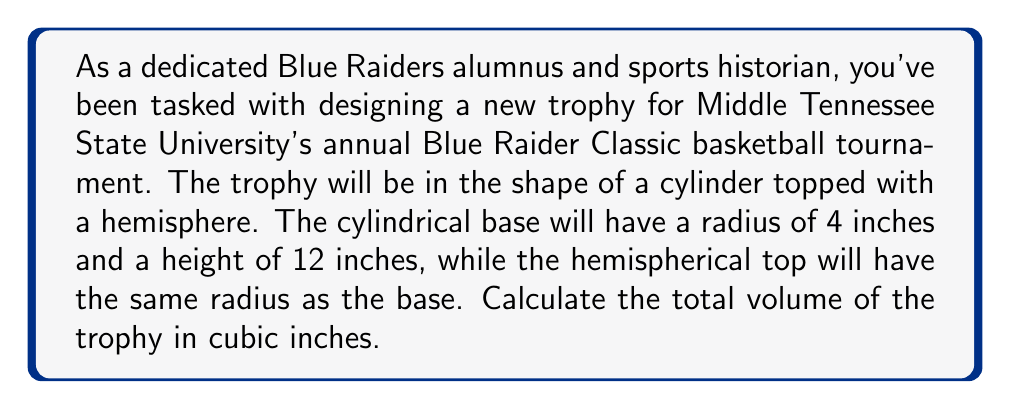Provide a solution to this math problem. Let's break this problem down into steps:

1. Calculate the volume of the cylindrical base:
   The formula for the volume of a cylinder is $V_c = \pi r^2 h$
   Where $r$ is the radius and $h$ is the height
   $$V_c = \pi (4\text{ in})^2 (12\text{ in}) = 192\pi \text{ in}^3$$

2. Calculate the volume of the hemispherical top:
   The formula for the volume of a sphere is $V_s = \frac{4}{3}\pi r^3$
   A hemisphere is half of this, so we use $V_h = \frac{1}{2} \cdot \frac{4}{3}\pi r^3 = \frac{2}{3}\pi r^3$
   $$V_h = \frac{2}{3}\pi (4\text{ in})^3 = \frac{128}{3}\pi \text{ in}^3$$

3. Sum the volumes to get the total volume:
   $$V_{\text{total}} = V_c + V_h = 192\pi \text{ in}^3 + \frac{128}{3}\pi \text{ in}^3$$
   $$V_{\text{total}} = \left(192 + \frac{128}{3}\right)\pi \text{ in}^3 = \frac{704}{3}\pi \text{ in}^3$$

4. Simplify and round to two decimal places:
   $$V_{\text{total}} \approx 734.78 \text{ in}^3$$

[asy]
import three;

size(200);
currentprojection=perspective(6,3,2);

// Draw cylinder
draw(cylinder((0,0,0),4,12));

// Draw hemisphere
draw(shift(0,0,12)*surface(sphere(4)),blue);

// Labels
label("4 in", (5,0,6), E);
label("12 in", (0,-5,6), W);

[/asy]
Answer: The total volume of the Blue Raider Classic trophy is approximately 734.78 cubic inches. 